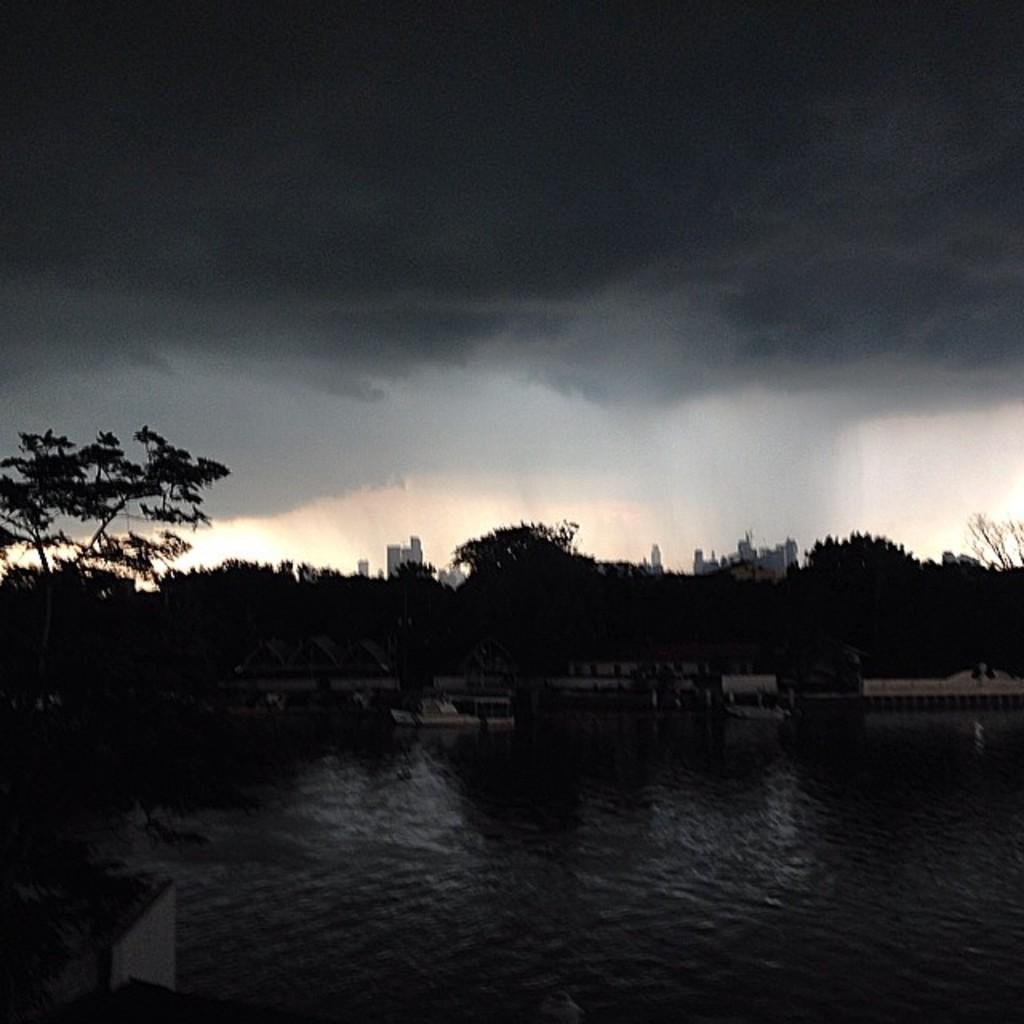How would you summarize this image in a sentence or two? In this image I can see a picture which is very dark. I can see water, few trees, few boats and few buildings. In the background I can see the sky. 